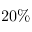Convert formula to latex. <formula><loc_0><loc_0><loc_500><loc_500>2 0 \%</formula> 